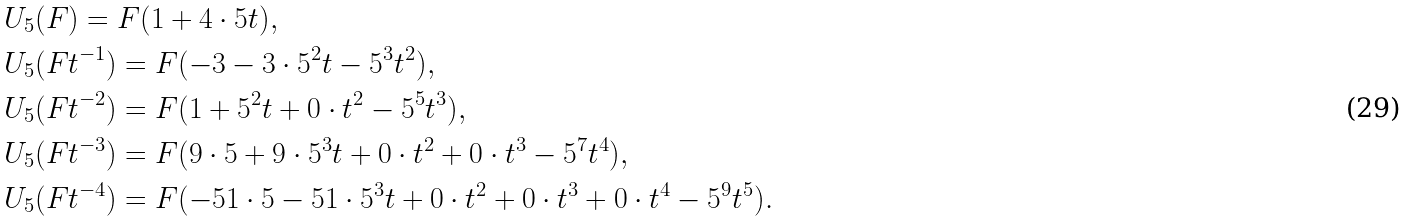<formula> <loc_0><loc_0><loc_500><loc_500>& U _ { 5 } ( F ) = F ( 1 + 4 \cdot 5 t ) , \\ & U _ { 5 } ( F t ^ { - 1 } ) = F ( - 3 - 3 \cdot 5 ^ { 2 } t - 5 ^ { 3 } t ^ { 2 } ) , \\ & U _ { 5 } ( F t ^ { - 2 } ) = F ( 1 + 5 ^ { 2 } t + 0 \cdot t ^ { 2 } - 5 ^ { 5 } t ^ { 3 } ) , \\ & U _ { 5 } ( F t ^ { - 3 } ) = F ( 9 \cdot 5 + 9 \cdot 5 ^ { 3 } t + 0 \cdot t ^ { 2 } + 0 \cdot t ^ { 3 } - 5 ^ { 7 } t ^ { 4 } ) , \\ & U _ { 5 } ( F t ^ { - 4 } ) = F ( - 5 1 \cdot 5 - 5 1 \cdot 5 ^ { 3 } t + 0 \cdot t ^ { 2 } + 0 \cdot t ^ { 3 } + 0 \cdot t ^ { 4 } - 5 ^ { 9 } t ^ { 5 } ) .</formula> 